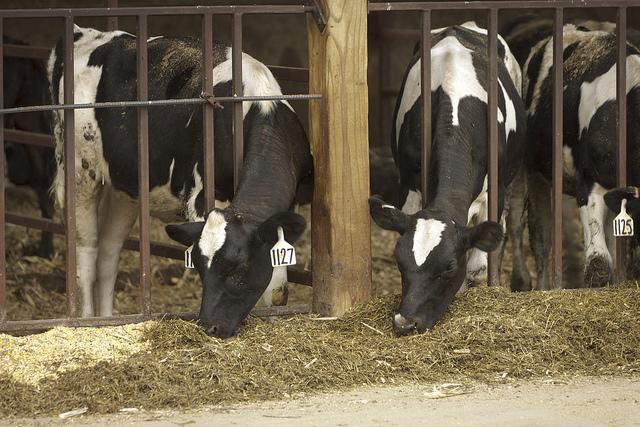Describe the environment where these cows are kept. The cows are in a barn or a stable, enclosed by metal bars. The ground is covered with hay or straw, and there are no indications of outdoor elements like grass or trees. 